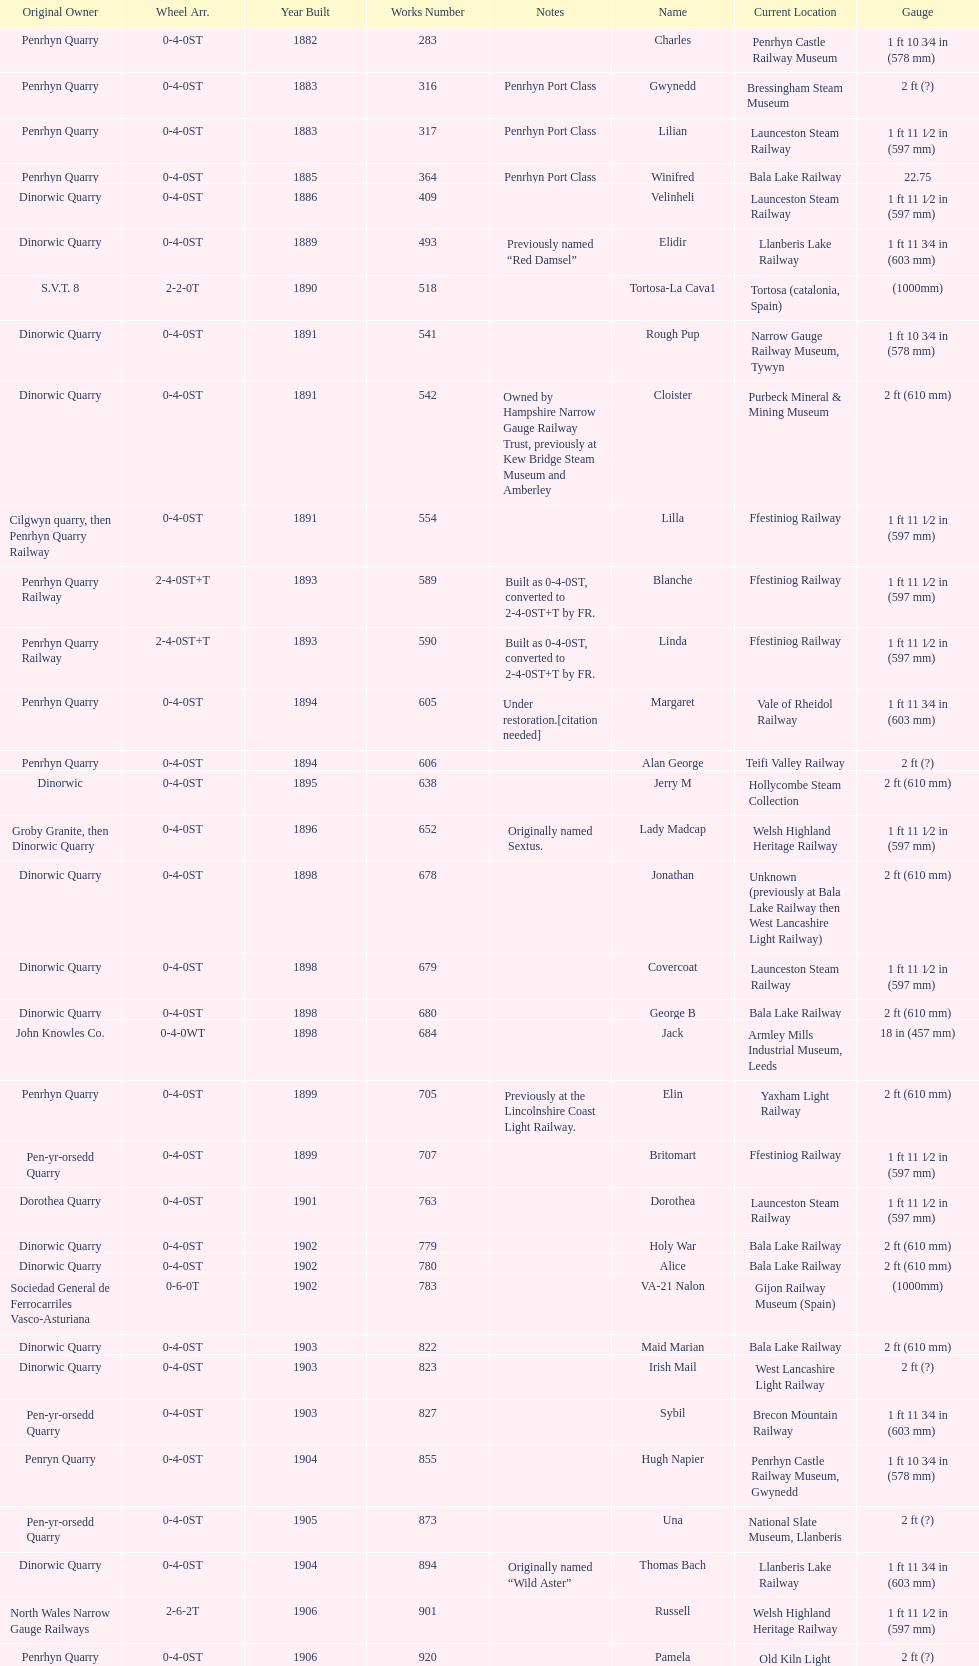Which works number had a larger gauge, 283 or 317? 317. 